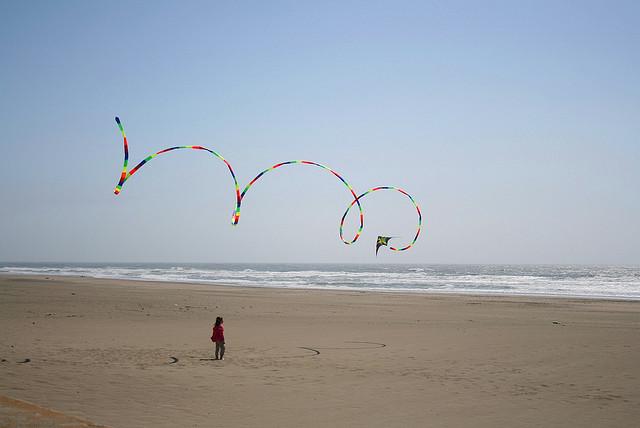How many people are standing on the beach?
Quick response, please. 1. What is the weather forecast in the picture?
Write a very short answer. Sunny. What is on the ground?
Write a very short answer. Sand. 